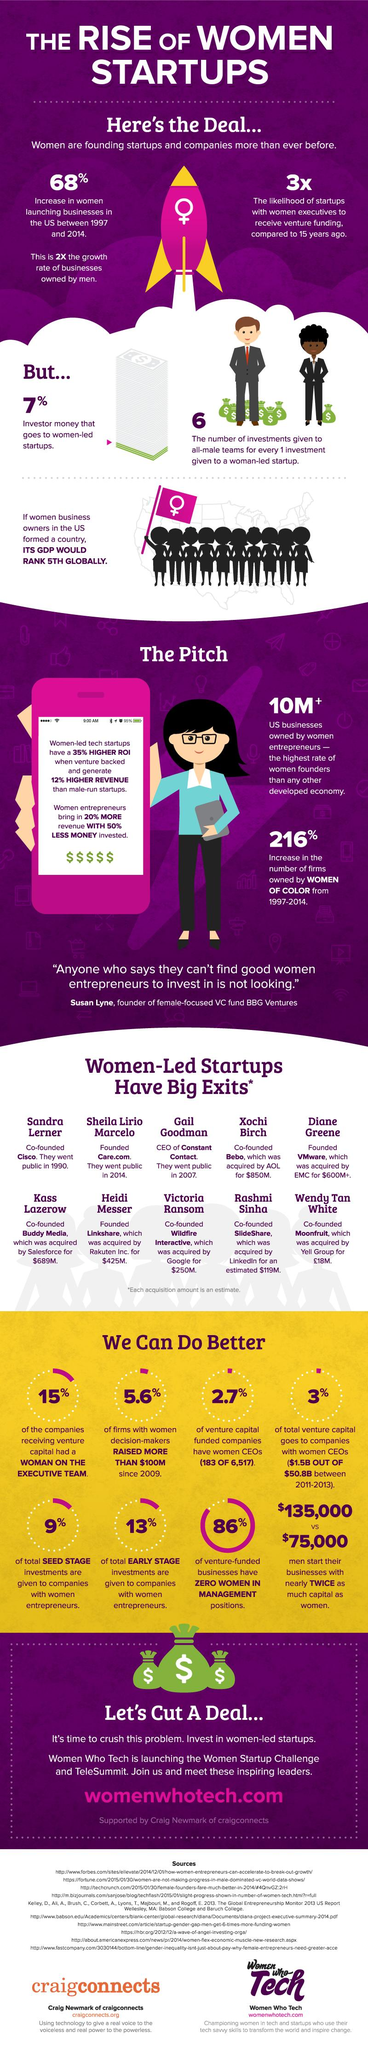Identify some key points in this picture. The prospect of receiving venture funding for women-led startups has increased by three times. Linkshare, a company, was acquired by Rakuten Inc. for $425 million. SlideShare was acquired by LinkedIn in 2012. Sandra Lerner was the co-founder of Cisco. Approximately 13% of total early-stage investments are allocated to companies with female entrepreneurs. 